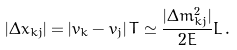<formula> <loc_0><loc_0><loc_500><loc_500>| \Delta { x } _ { k j } | = \left | v _ { k } - v _ { j } \right | T \simeq \frac { | \Delta { m } ^ { 2 } _ { k j } | } { 2 E } L \, .</formula> 